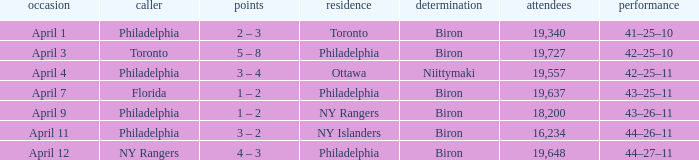Who were the visitors when the home team were the ny rangers? Philadelphia. 